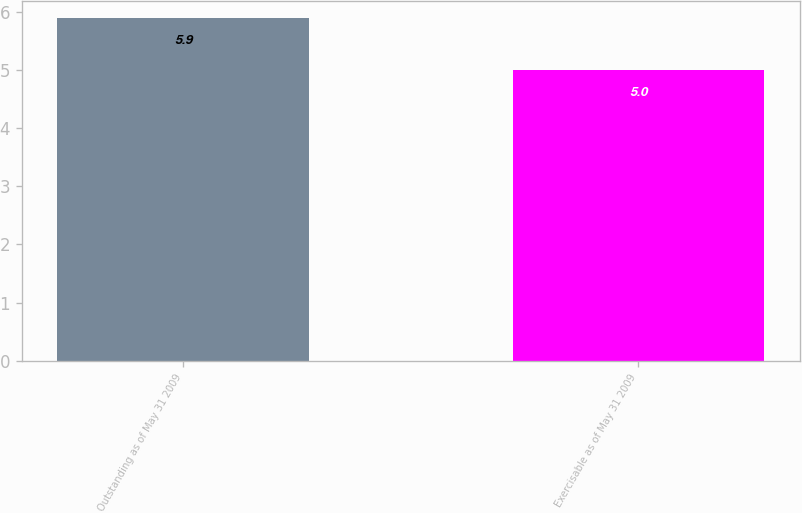<chart> <loc_0><loc_0><loc_500><loc_500><bar_chart><fcel>Outstanding as of May 31 2009<fcel>Exercisable as of May 31 2009<nl><fcel>5.9<fcel>5<nl></chart> 